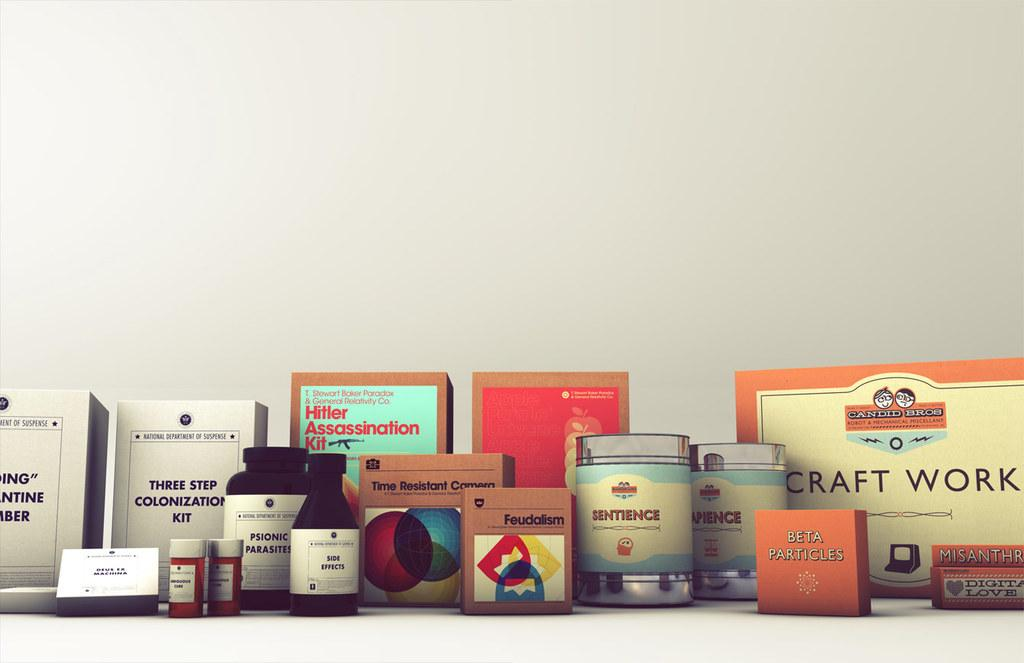<image>
Give a short and clear explanation of the subsequent image. A shelf full of boxes and jars of odd items one being Hitler Assassination kit. 